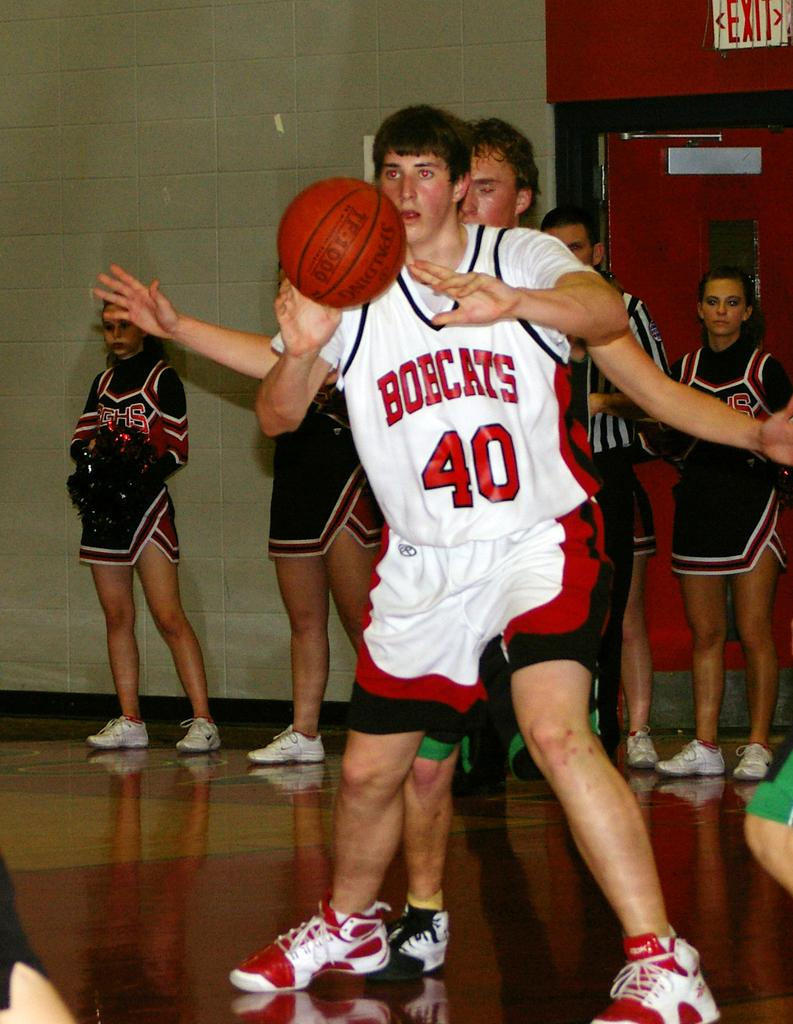<image>
Write a terse but informative summary of the picture. Bobcats number 40 attempts to keep control of the basketball. 